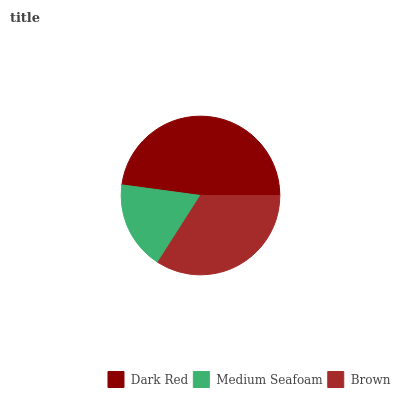Is Medium Seafoam the minimum?
Answer yes or no. Yes. Is Dark Red the maximum?
Answer yes or no. Yes. Is Brown the minimum?
Answer yes or no. No. Is Brown the maximum?
Answer yes or no. No. Is Brown greater than Medium Seafoam?
Answer yes or no. Yes. Is Medium Seafoam less than Brown?
Answer yes or no. Yes. Is Medium Seafoam greater than Brown?
Answer yes or no. No. Is Brown less than Medium Seafoam?
Answer yes or no. No. Is Brown the high median?
Answer yes or no. Yes. Is Brown the low median?
Answer yes or no. Yes. Is Medium Seafoam the high median?
Answer yes or no. No. Is Dark Red the low median?
Answer yes or no. No. 